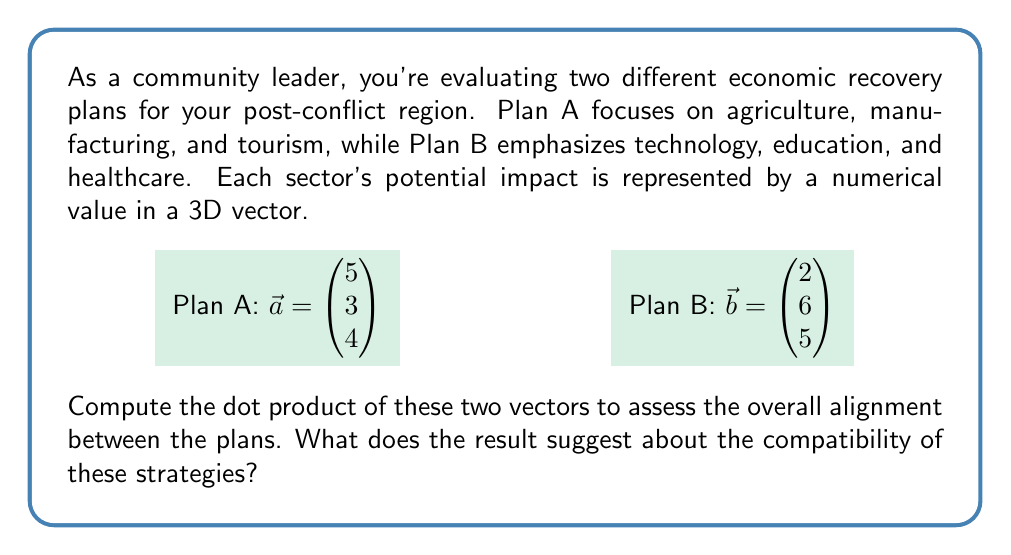Solve this math problem. To compute the dot product of vectors $\vec{a}$ and $\vec{b}$, we multiply corresponding components and sum the results:

$$\vec{a} \cdot \vec{b} = a_1b_1 + a_2b_2 + a_3b_3$$

Substituting the values:

$$\vec{a} \cdot \vec{b} = (5)(2) + (3)(6) + (4)(5)$$

$$\vec{a} \cdot \vec{b} = 10 + 18 + 20$$

$$\vec{a} \cdot \vec{b} = 48$$

The dot product is 48, which is positive and relatively large considering the magnitudes of the vectors. This suggests that the two plans have a significant degree of alignment or compatibility.

Interpretation:
1. Positive result: The plans are generally moving in the same direction, indicating some level of agreement in overall strategy.
2. Magnitude: The relatively large value suggests substantial overlap in priorities, despite the different focus areas.
3. Economic implications: While Plan A emphasizes traditional sectors and Plan B focuses on modern sectors, the positive dot product indicates that these approaches might be complementary rather than conflicting.

As a community leader, this result suggests that elements from both plans could potentially be combined or implemented in parallel for a more comprehensive recovery strategy.
Answer: 48; indicates significant alignment between the two economic recovery plans 